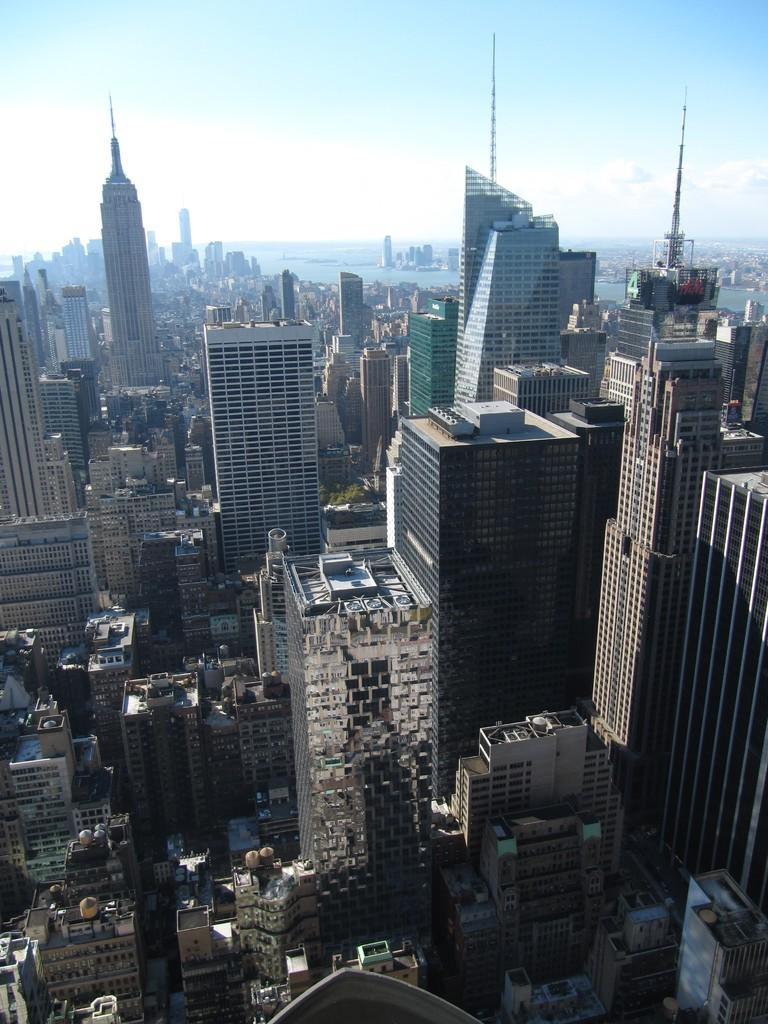What type of structures can be seen in the image? There are many buildings and skyscrapers in the image. What part of the natural environment is visible in the image? The sky is visible in the image. What is the color of the sky in the image? The color of the sky is blue. What type of apparel is being worn by the yam in the image? There is no yam present in the image, and therefore no apparel can be associated with it. 